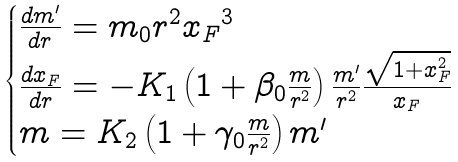Convert formula to latex. <formula><loc_0><loc_0><loc_500><loc_500>\begin{cases} \frac { d m ^ { \prime } } { d r } = m _ { 0 } r ^ { 2 } { x _ { F } } ^ { 3 } \\ \frac { d x _ { F } } { d r } = - K _ { 1 } \left ( 1 + \beta _ { 0 } \frac { m } { r ^ { 2 } } \right ) \frac { m ^ { \prime } } { r ^ { 2 } } \frac { \sqrt { 1 + x _ { F } ^ { 2 } } } { x _ { F } } \\ m = K _ { 2 } \left ( 1 + \gamma _ { 0 } \frac { m } { r ^ { 2 } } \right ) m ^ { \prime } \end{cases}</formula> 